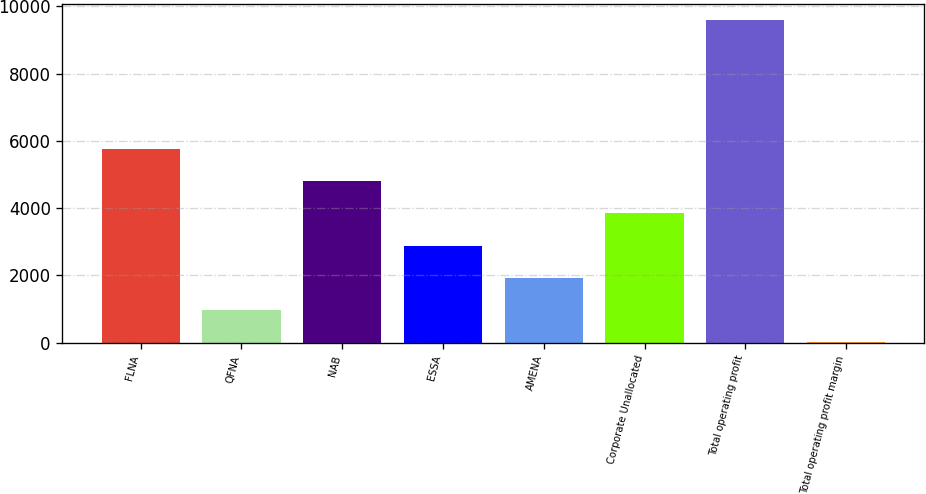<chart> <loc_0><loc_0><loc_500><loc_500><bar_chart><fcel>FLNA<fcel>QFNA<fcel>NAB<fcel>ESSA<fcel>AMENA<fcel>Corporate Unallocated<fcel>Total operating profit<fcel>Total operating profit margin<nl><fcel>5754.36<fcel>971.06<fcel>4797.7<fcel>2884.38<fcel>1927.72<fcel>3841.04<fcel>9581<fcel>14.4<nl></chart> 